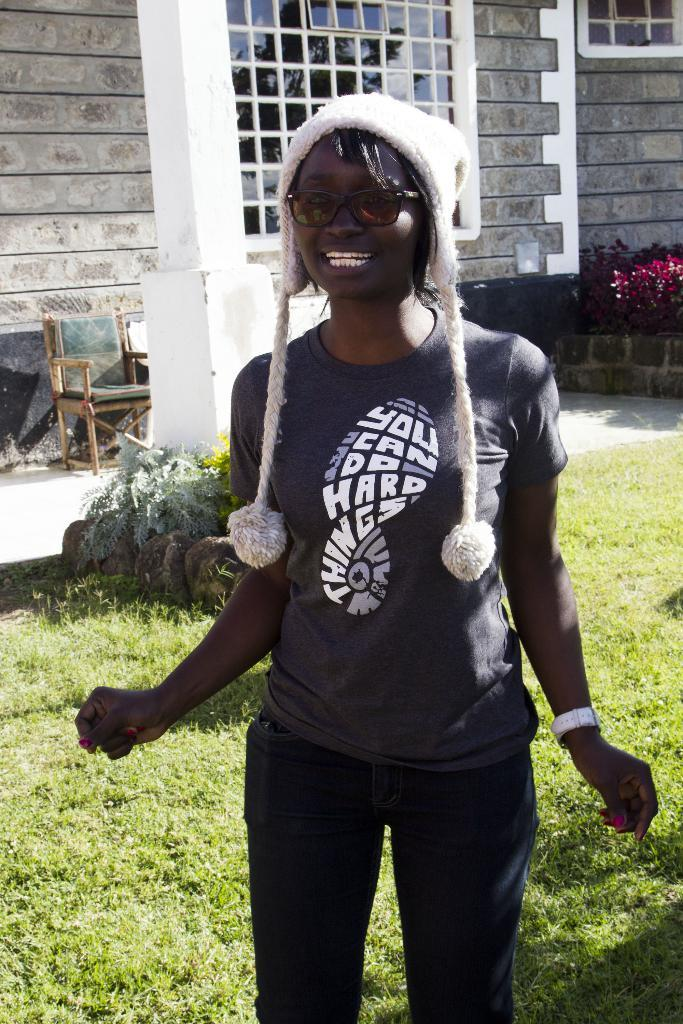What is the main subject of the image? The main subject of the image is a woman. What is the woman doing in the image? The woman is standing in the image. What can be seen on the woman's head in the image? The woman is wearing a white-colored cap in the image. What type of frame is visible around the woman in the image? There is no frame visible around the woman in the image. What kind of meal is the woman holding in the image? The image does not show the woman holding any meal. 